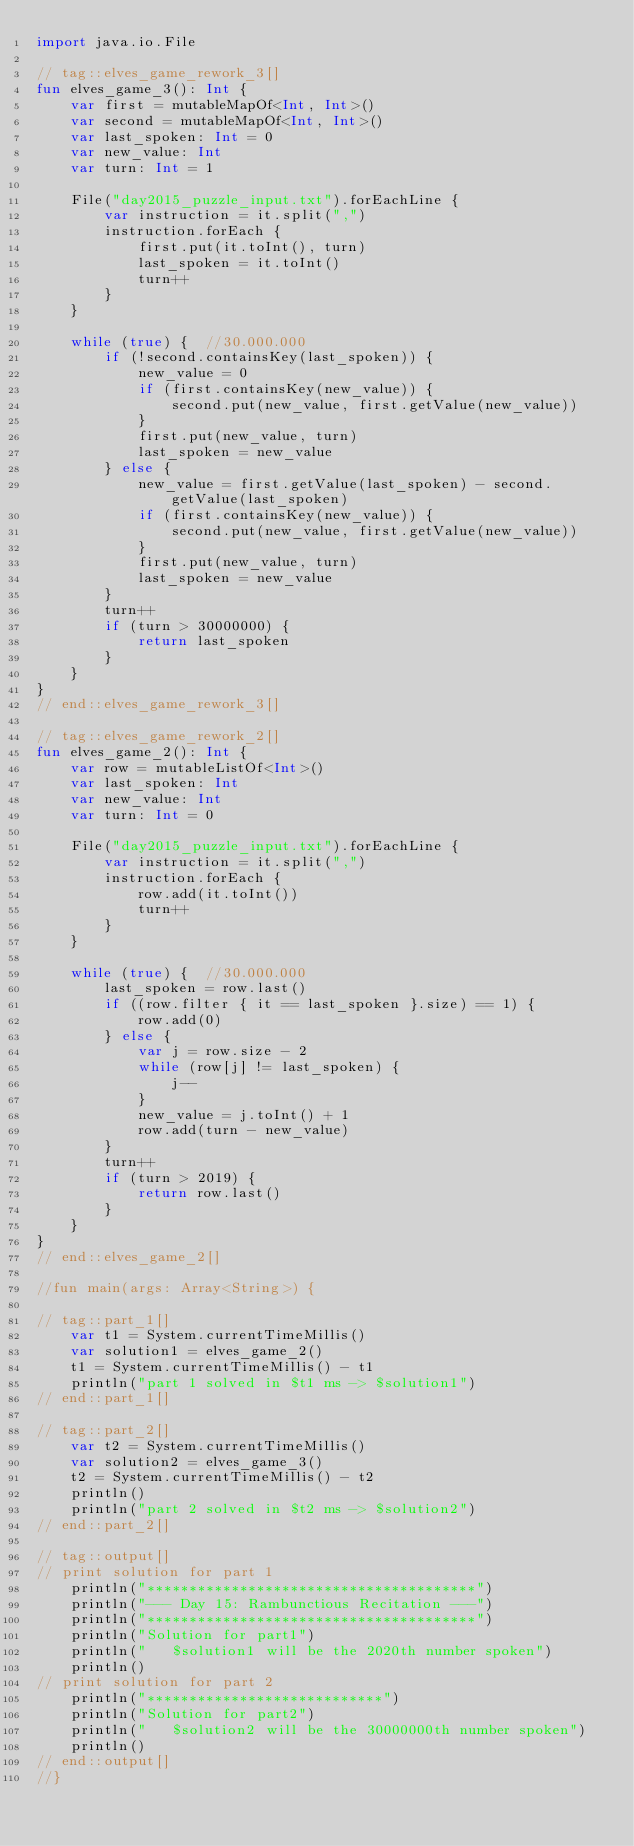<code> <loc_0><loc_0><loc_500><loc_500><_Kotlin_>import java.io.File

// tag::elves_game_rework_3[]
fun elves_game_3(): Int {
	var first = mutableMapOf<Int, Int>()
	var second = mutableMapOf<Int, Int>()
	var last_spoken: Int = 0
	var new_value: Int
	var turn: Int = 1
	
	File("day2015_puzzle_input.txt").forEachLine {
		var instruction = it.split(",")
		instruction.forEach {
			first.put(it.toInt(), turn)
			last_spoken = it.toInt()
			turn++
		}
	}

	while (true) {  //30.000.000
		if (!second.containsKey(last_spoken)) {
			new_value = 0
			if (first.containsKey(new_value)) {
				second.put(new_value, first.getValue(new_value))
			}
			first.put(new_value, turn)
			last_spoken = new_value
		} else {
			new_value = first.getValue(last_spoken) - second.getValue(last_spoken)
			if (first.containsKey(new_value)) {
				second.put(new_value, first.getValue(new_value))
			}
			first.put(new_value, turn)
			last_spoken = new_value
		}
		turn++
		if (turn > 30000000) {
			return last_spoken
		}
	}
}
// end::elves_game_rework_3[]

// tag::elves_game_rework_2[]
fun elves_game_2(): Int {
	var row = mutableListOf<Int>()
	var last_spoken: Int
	var new_value: Int 
	var turn: Int = 0
	
	File("day2015_puzzle_input.txt").forEachLine {
		var instruction = it.split(",")
		instruction.forEach {
			row.add(it.toInt())
			turn++
		}
	}

	while (true) {  //30.000.000
		last_spoken = row.last()
		if ((row.filter { it == last_spoken }.size) == 1) {
			row.add(0)
		} else {
			var j = row.size - 2
			while (row[j] != last_spoken) {
				j--
			}
			new_value = j.toInt() + 1
			row.add(turn - new_value)
		}
		turn++
		if (turn > 2019) {
			return row.last()
		}
	}
}
// end::elves_game_2[]

//fun main(args: Array<String>) {

// tag::part_1[]
	var t1 = System.currentTimeMillis()
	var solution1 = elves_game_2()
	t1 = System.currentTimeMillis() - t1
	println("part 1 solved in $t1 ms -> $solution1")
// end::part_1[]

// tag::part_2[]
	var t2 = System.currentTimeMillis()
	var solution2 = elves_game_3()
	t2 = System.currentTimeMillis() - t2
	println()
	println("part 2 solved in $t2 ms -> $solution2")
// end::part_2[]

// tag::output[]
// print solution for part 1
	println("***************************************")
	println("--- Day 15: Rambunctious Recitation ---")
	println("***************************************")
	println("Solution for part1")
	println("   $solution1 will be the 2020th number spoken")
	println()
// print solution for part 2
	println("****************************")
	println("Solution for part2")
	println("   $solution2 will be the 30000000th number spoken")
	println()
// end::output[]
//}	</code> 